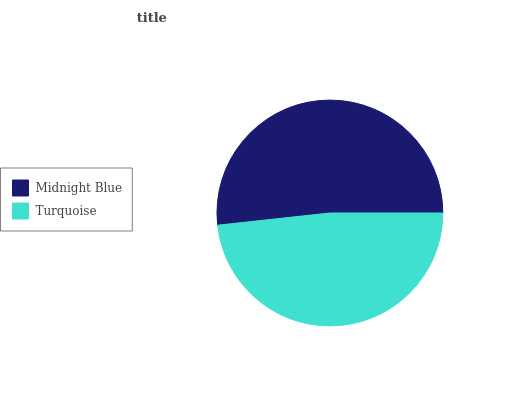Is Turquoise the minimum?
Answer yes or no. Yes. Is Midnight Blue the maximum?
Answer yes or no. Yes. Is Turquoise the maximum?
Answer yes or no. No. Is Midnight Blue greater than Turquoise?
Answer yes or no. Yes. Is Turquoise less than Midnight Blue?
Answer yes or no. Yes. Is Turquoise greater than Midnight Blue?
Answer yes or no. No. Is Midnight Blue less than Turquoise?
Answer yes or no. No. Is Midnight Blue the high median?
Answer yes or no. Yes. Is Turquoise the low median?
Answer yes or no. Yes. Is Turquoise the high median?
Answer yes or no. No. Is Midnight Blue the low median?
Answer yes or no. No. 